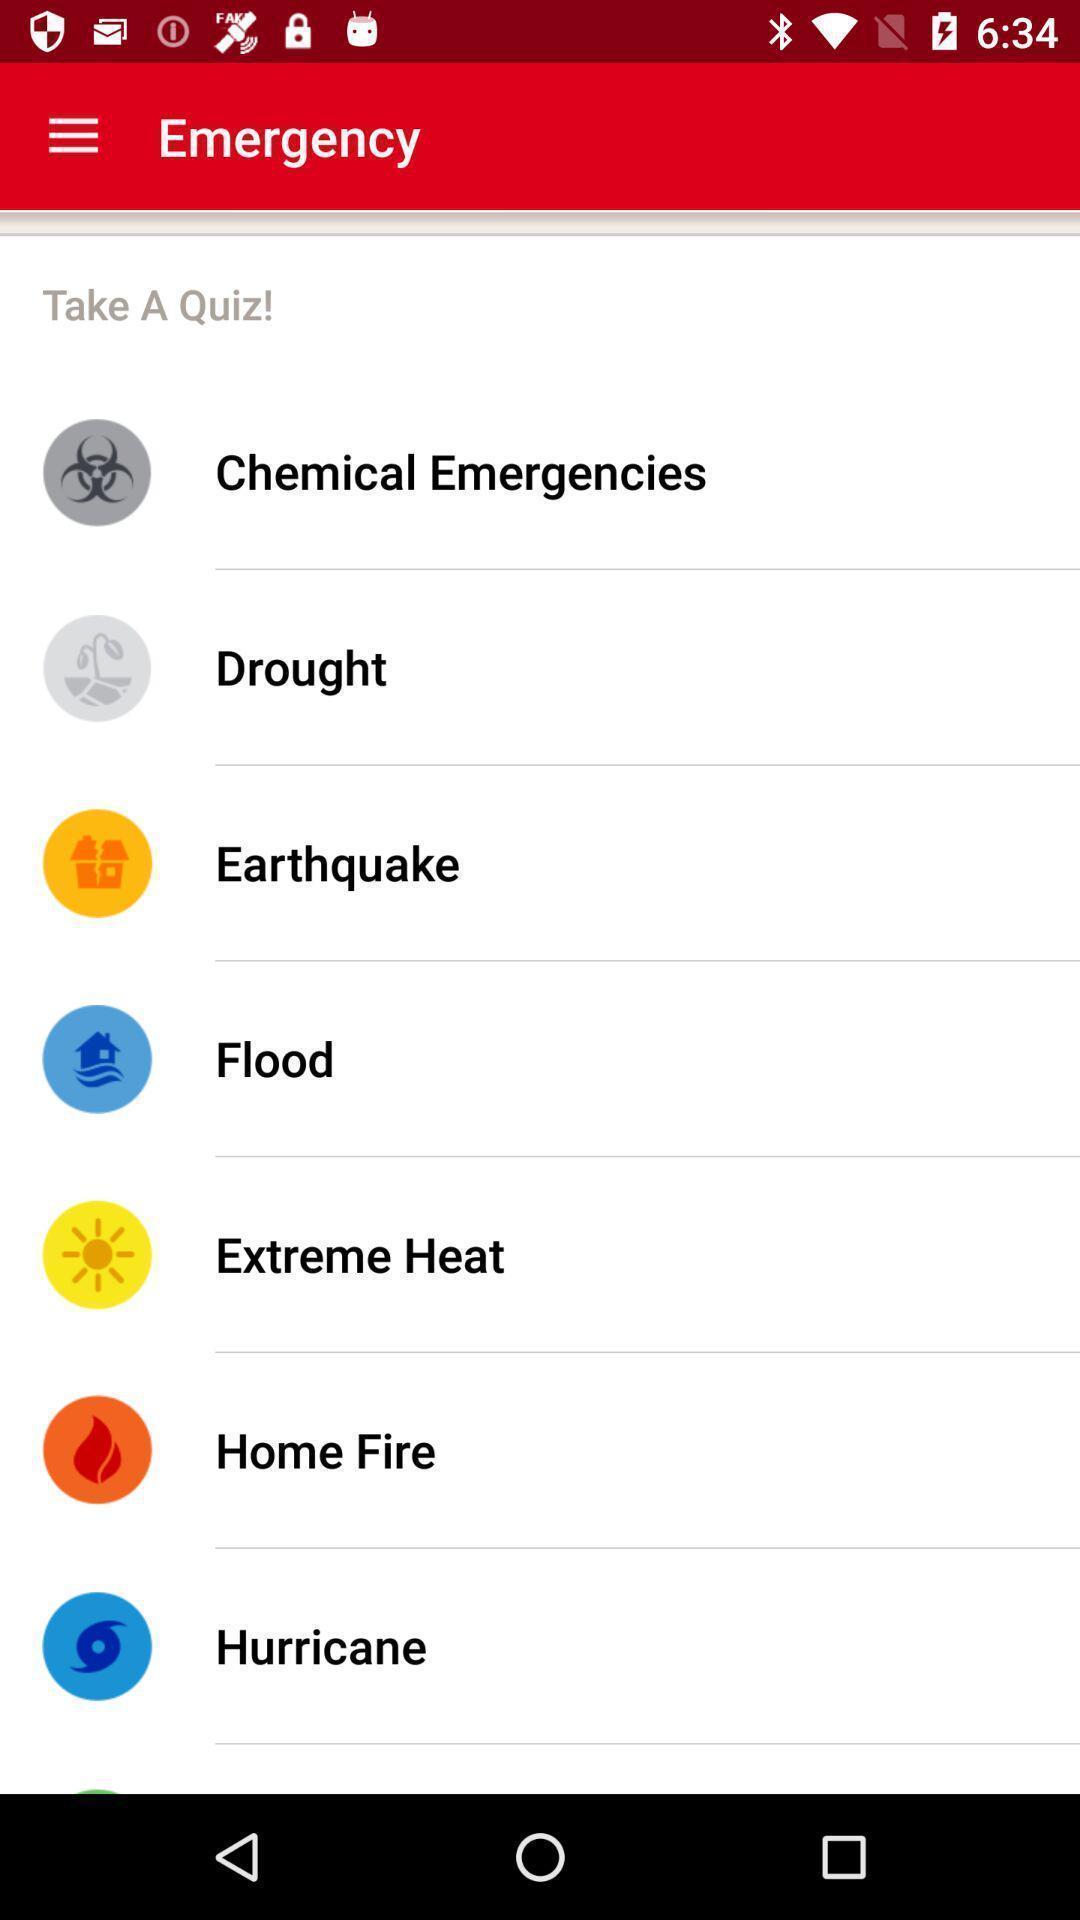Provide a textual representation of this image. Screen displaying multiple emergency topics with icons and names. 